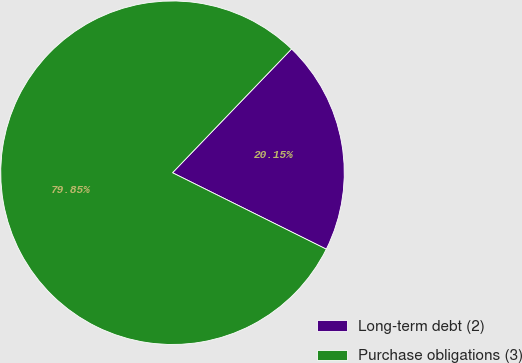<chart> <loc_0><loc_0><loc_500><loc_500><pie_chart><fcel>Long-term debt (2)<fcel>Purchase obligations (3)<nl><fcel>20.15%<fcel>79.85%<nl></chart> 